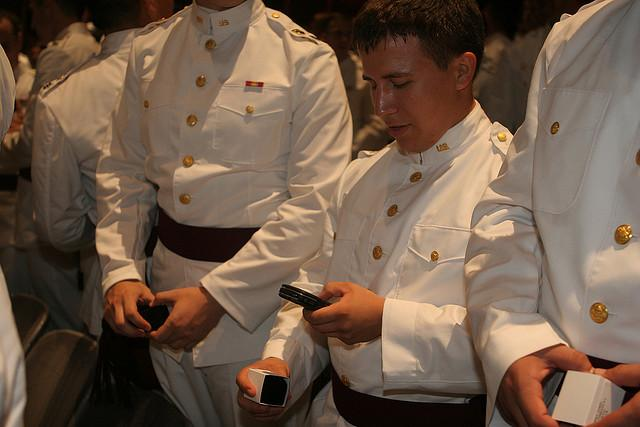What is the short man doing? Please explain your reasoning. taking photo. The man takes photos. 